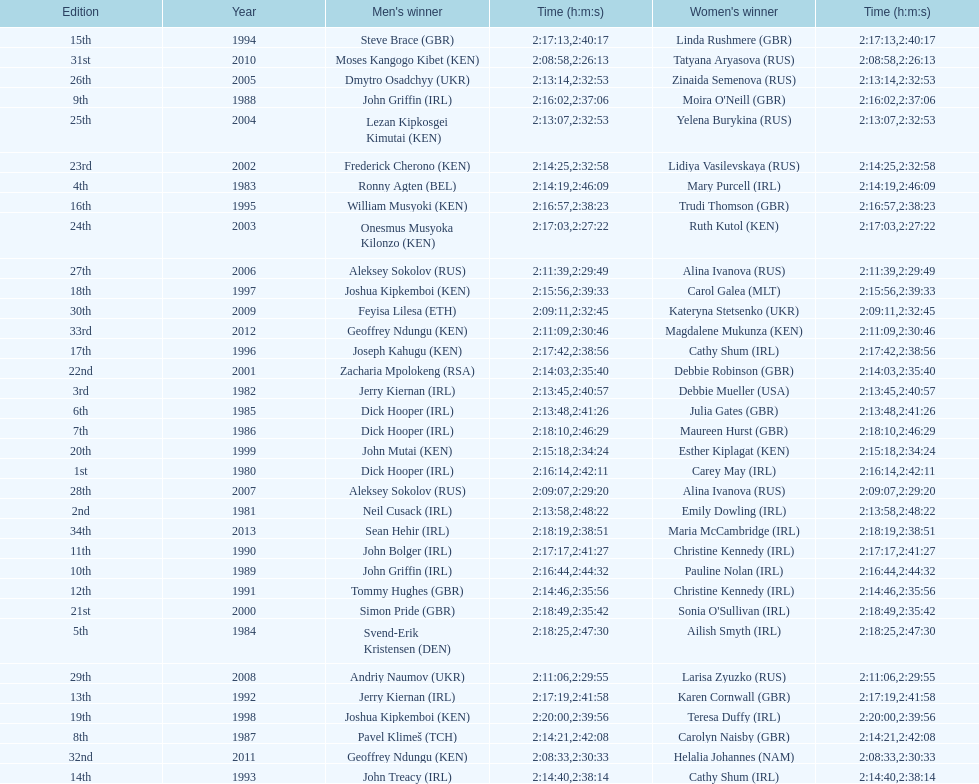In 2009, which competitor finished faster - the male or the female? Male. 